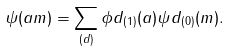<formula> <loc_0><loc_0><loc_500><loc_500>\psi ( a m ) = \sum _ { ( d ) } \phi d _ { ( 1 ) } ( a ) \psi d _ { ( 0 ) } ( m ) .</formula> 